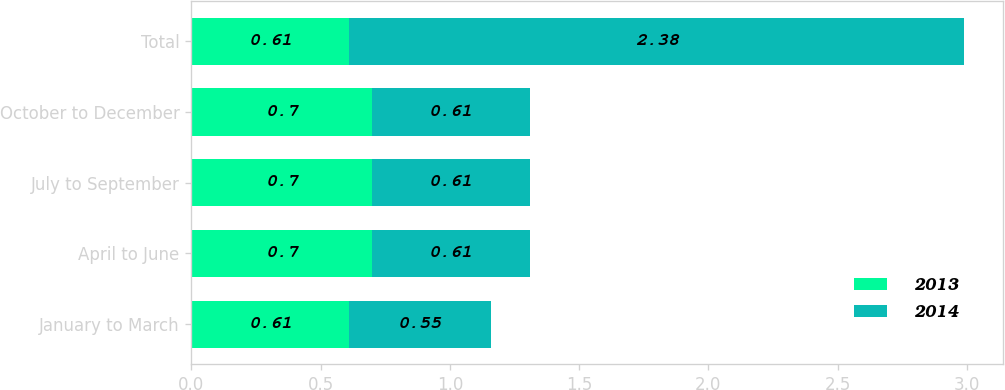Convert chart to OTSL. <chart><loc_0><loc_0><loc_500><loc_500><stacked_bar_chart><ecel><fcel>January to March<fcel>April to June<fcel>July to September<fcel>October to December<fcel>Total<nl><fcel>2013<fcel>0.61<fcel>0.7<fcel>0.7<fcel>0.7<fcel>0.61<nl><fcel>2014<fcel>0.55<fcel>0.61<fcel>0.61<fcel>0.61<fcel>2.38<nl></chart> 